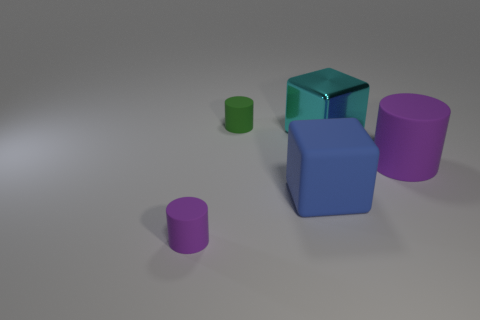Subtract all tiny green cylinders. How many cylinders are left? 2 Add 1 big yellow shiny cylinders. How many objects exist? 6 Subtract all cyan blocks. How many purple cylinders are left? 2 Subtract 1 cylinders. How many cylinders are left? 2 Subtract all purple cylinders. How many cylinders are left? 1 Subtract all cylinders. How many objects are left? 2 Add 2 yellow cylinders. How many yellow cylinders exist? 2 Subtract 0 brown cylinders. How many objects are left? 5 Subtract all green cubes. Subtract all cyan cylinders. How many cubes are left? 2 Subtract all big red rubber cylinders. Subtract all green objects. How many objects are left? 4 